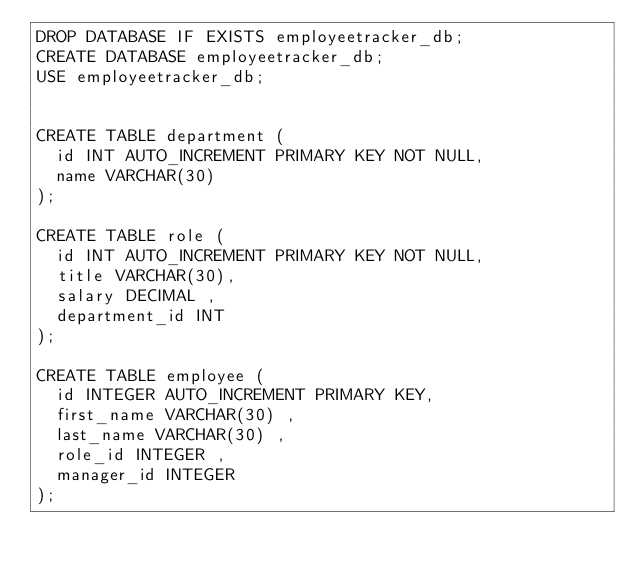Convert code to text. <code><loc_0><loc_0><loc_500><loc_500><_SQL_>DROP DATABASE IF EXISTS employeetracker_db;
CREATE DATABASE employeetracker_db;
USE employeetracker_db;


CREATE TABLE department (
  id INT AUTO_INCREMENT PRIMARY KEY NOT NULL,
  name VARCHAR(30)
);

CREATE TABLE role (
  id INT AUTO_INCREMENT PRIMARY KEY NOT NULL,
  title VARCHAR(30),
  salary DECIMAL ,
  department_id INT
);

CREATE TABLE employee (
  id INTEGER AUTO_INCREMENT PRIMARY KEY,
  first_name VARCHAR(30) ,
  last_name VARCHAR(30) ,
  role_id INTEGER ,
  manager_id INTEGER 
);</code> 